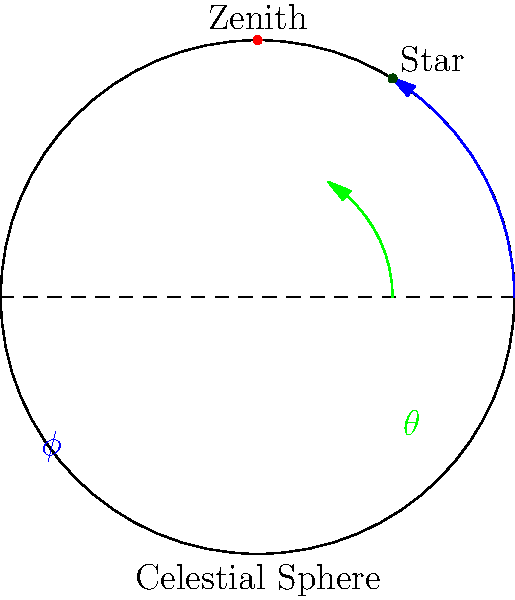In the azimuthal coordinate system shown, a star's position is given by its azimuth ($\phi$) and altitude ($\theta$) angles. If the star's apparent motion causes its azimuth to increase by 15° every hour while its altitude remains constant, what is the star's angular velocity in radians per hour with respect to the azimuth? To solve this problem, we need to follow these steps:

1) First, recall that angular velocity ($\omega$) is the rate of change of angular displacement with respect to time. In this case, we're interested in the change of azimuth angle over time.

2) We're given that the azimuth increases by 15° every hour. This is our angular displacement per unit time.

3) However, we need to convert this to radians, as angular velocity is typically expressed in radians per unit time. The conversion factor from degrees to radians is:

   $$\frac{\pi \text{ radians}}{180°}$$

4) So, let's convert 15° to radians:

   $$15° \times \frac{\pi \text{ radians}}{180°} = \frac{\pi}{12} \text{ radians}$$

5) This means the star's azimuth is changing by $\frac{\pi}{12}$ radians every hour.

6) By definition, this rate of change is the angular velocity. Therefore, the star's angular velocity with respect to azimuth is $\frac{\pi}{12}$ radians per hour.
Answer: $\frac{\pi}{12}$ rad/hr 